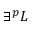Convert formula to latex. <formula><loc_0><loc_0><loc_500><loc_500>\exists ^ { p } L</formula> 